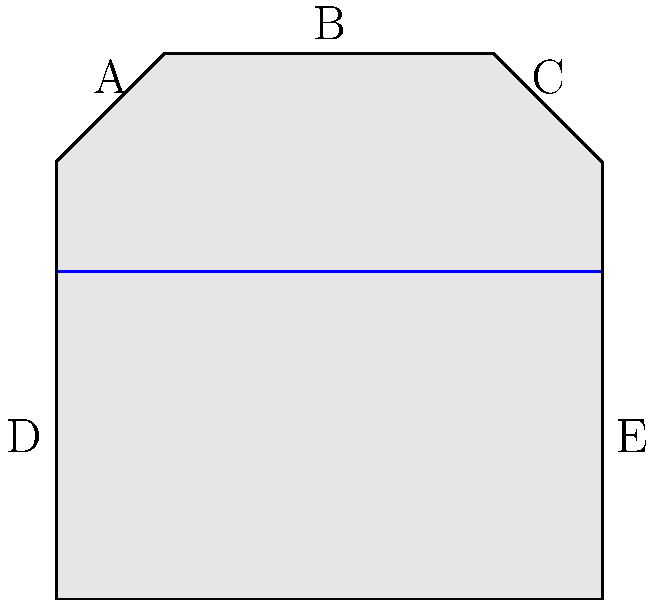Examine the cross-sectional diagram of a dam structure. Based on your experience in assessing structural integrity, which labeled point(s) would you identify as potential weak points that require immediate attention to prevent failure? To identify potential weak points in the dam structure, we need to consider several factors:

1. Stress concentration: Areas where the shape changes abruptly are prone to stress concentration.
2. Water pressure: The areas in contact with water experience higher pressure, especially at greater depths.
3. Foundation stability: The base of the dam must withstand the entire weight and water pressure.

Analyzing each point:

A: This point is at the top corner of the dam, where two surfaces meet at an angle. It's a potential stress concentration point but experiences less water pressure due to its height.

B: The top of the dam experiences minimal stress and water pressure, making it less likely to be a weak point.

C: Similar to point A, it's a potential stress concentration point but with less water pressure.

D: This point is at the base of the dam where it meets the foundation. It experiences high water pressure and bears the weight of the structure above it. The sharp angle here also creates a stress concentration point.

E: Similar to point D, this is also a critical area due to high water pressure, structural load, and potential for stress concentration.

Based on this analysis, points D and E are the most critical potential weak points. They experience the highest combination of stresses and are crucial for the overall stability of the dam.
Answer: Points D and E 